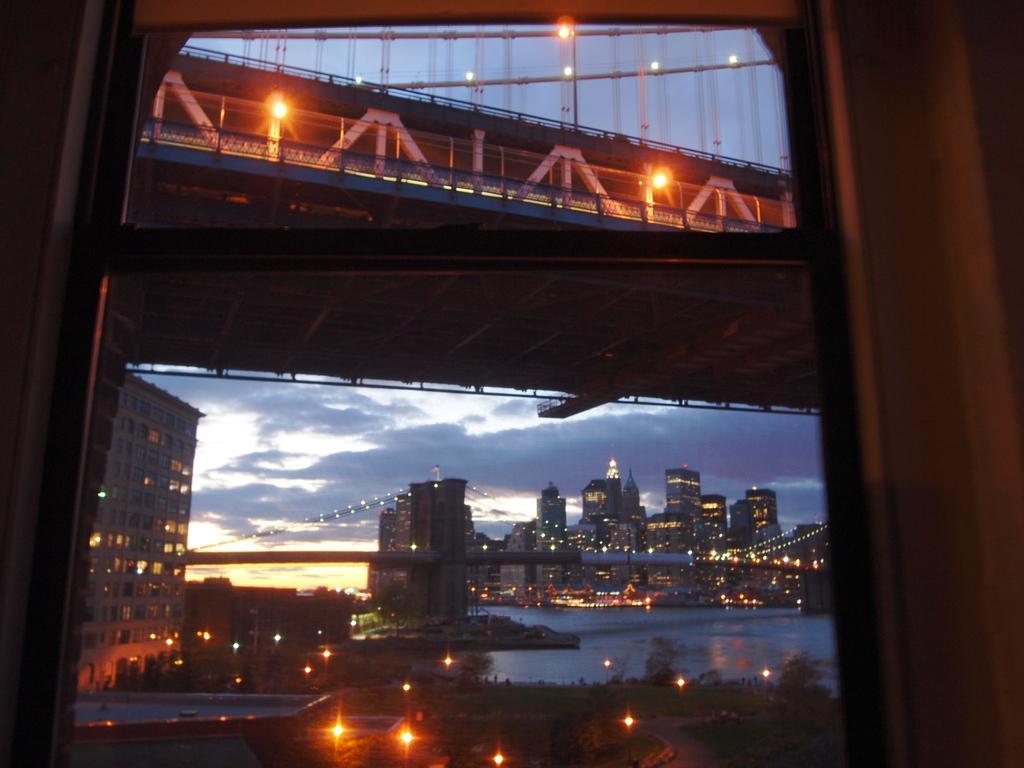How would you summarize this image in a sentence or two? In this picture there are buildings in the center of the image and there is water at the bottom side of the image, there is a bridge at the top side of the image, it seems to be the picture is captured during night time. 